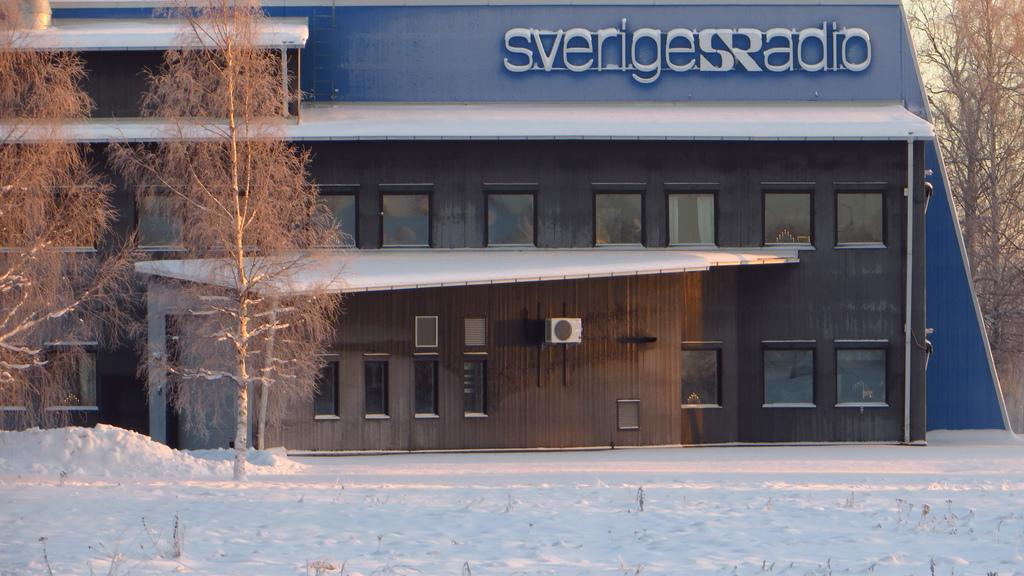What type of structure is present in the image? There is a building in the image. What features can be observed on the building? The building has windows, a roof, and an air conditioner. Is there any text visible on the building? Yes, there is a sign board with text on the building. What can be seen in the background of the image? There is a group of trees and the sky visible in the background of the image. How many lizards can be seen climbing on the building in the image? There are no lizards visible in the image; it only shows a building with windows, a roof, an air conditioner, and a sign board. 